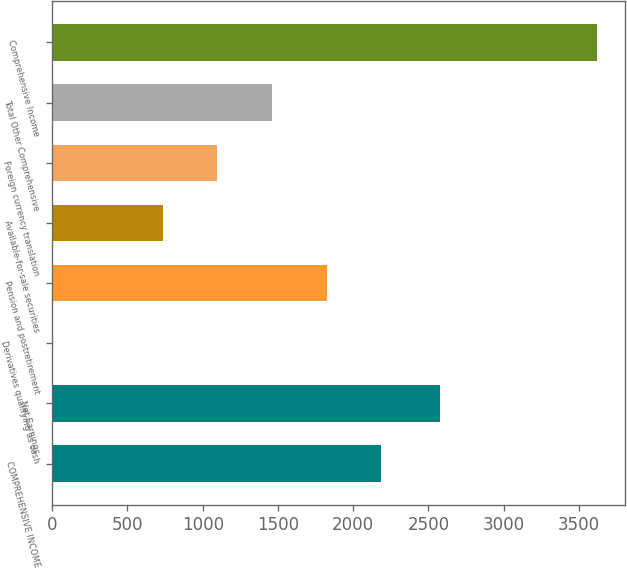<chart> <loc_0><loc_0><loc_500><loc_500><bar_chart><fcel>COMPREHENSIVE INCOME<fcel>Net Earnings<fcel>Derivatives qualifying as cash<fcel>Pension and postretirement<fcel>Available-for-sale securities<fcel>Foreign currency translation<fcel>Total Other Comprehensive<fcel>Comprehensive Income<nl><fcel>2187.4<fcel>2580<fcel>7<fcel>1824<fcel>733.8<fcel>1097.2<fcel>1460.6<fcel>3624<nl></chart> 